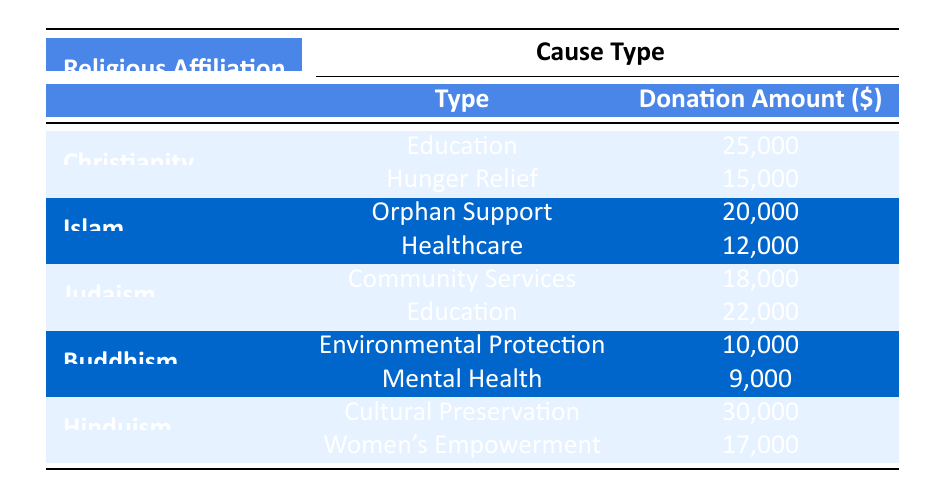What is the total donation amount for Christianity? The table shows two donation amounts for Christianity: 25,000 for Education and 15,000 for Hunger Relief. By adding these together, we get 25,000 + 15,000 = 40,000.
Answer: 40,000 Which cause type received the highest donation from Hinduism? In the table, Hinduism has donations for two causes: 30,000 for Cultural Preservation and 17,000 for Women's Empowerment. Since 30,000 is greater than 17,000, the highest donation amount is for Cultural Preservation.
Answer: Cultural Preservation True or False: Judaism donated more to Community Services than Islam donated to Healthcare. Judaism donated 18,000 for Community Services, while Islam donated 12,000 for Healthcare. Since 18,000 is greater than 12,000, the statement is true.
Answer: True What is the average donation amount for all causes under Buddhism? Buddhism has donations of 10,000 for Environmental Protection and 9,000 for Mental Health. To calculate the average, we sum these amounts: 10,000 + 9,000 = 19,000. Since there are two donations, we divide by 2: 19,000 / 2 = 9,500.
Answer: 9,500 Which religious affiliation contributed the least amount to its causes? In the table, Buddhism has the lowest total donation amounts with 10,000 for Environmental Protection and 9,000 for Mental Health. Adding these amounts, we get 10,000 + 9,000 = 19,000. Other affiliations have higher totals, showing Buddhism contributed the least.
Answer: Buddhism 